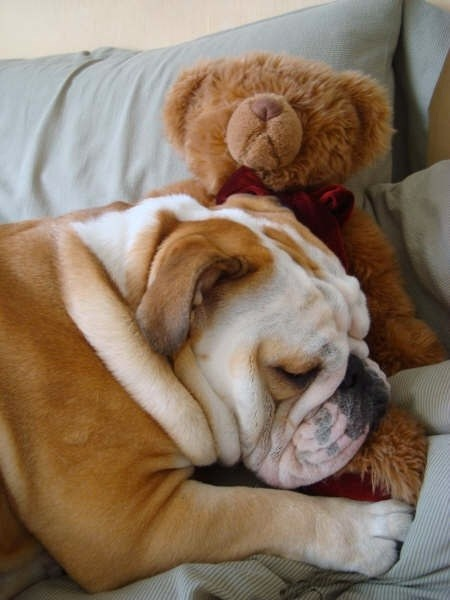Describe the objects in this image and their specific colors. I can see dog in lightgray, olive, darkgray, maroon, and gray tones, couch in lightgray, darkgray, gray, and black tones, bed in lightgray, darkgray, gray, and black tones, and teddy bear in lightgray, maroon, black, and gray tones in this image. 